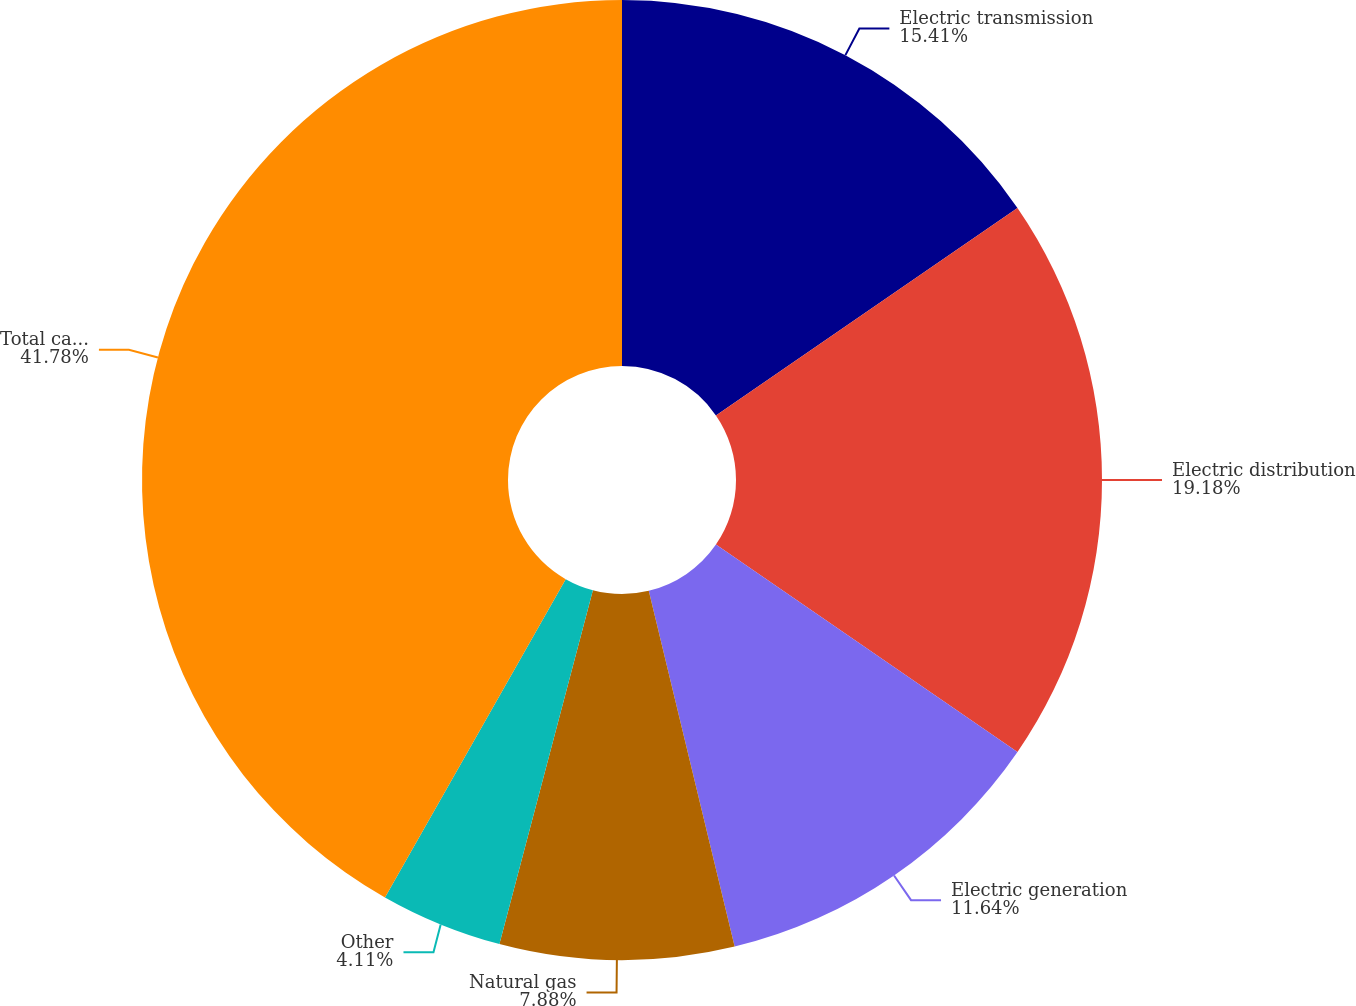Convert chart. <chart><loc_0><loc_0><loc_500><loc_500><pie_chart><fcel>Electric transmission<fcel>Electric distribution<fcel>Electric generation<fcel>Natural gas<fcel>Other<fcel>Total capital expenditures<nl><fcel>15.41%<fcel>19.18%<fcel>11.64%<fcel>7.88%<fcel>4.11%<fcel>41.78%<nl></chart> 